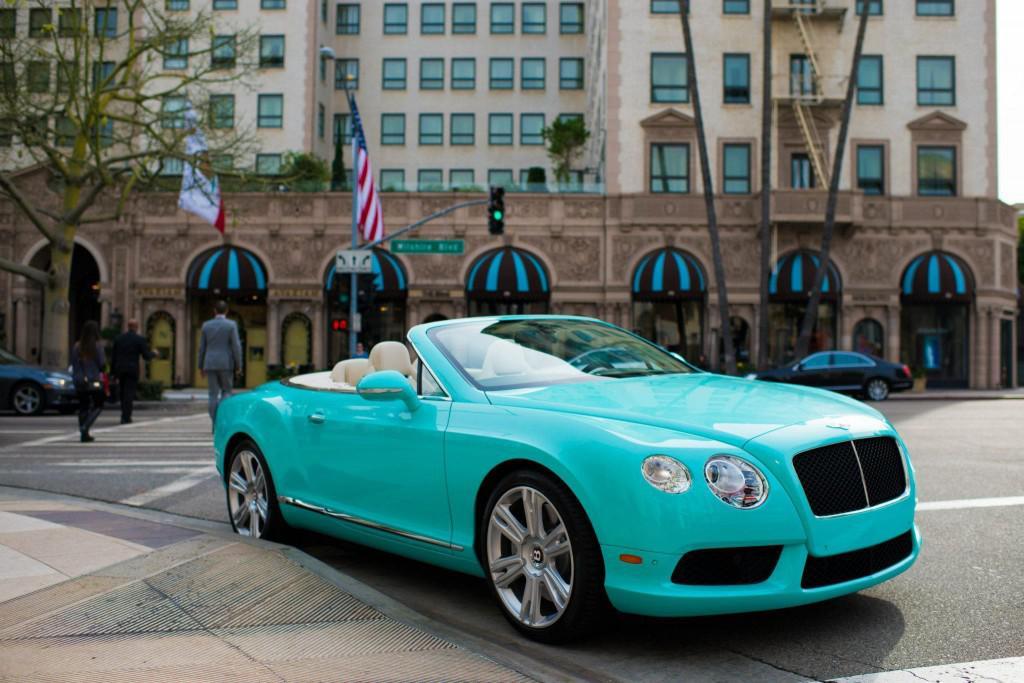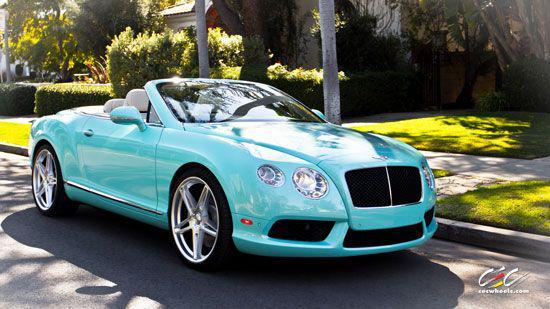The first image is the image on the left, the second image is the image on the right. For the images displayed, is the sentence "The top is up on the image on the left." factually correct? Answer yes or no. No. The first image is the image on the left, the second image is the image on the right. For the images shown, is this caption "The left image shows a convertible car with the top up while the right image shows a convertible with the top down" true? Answer yes or no. No. 